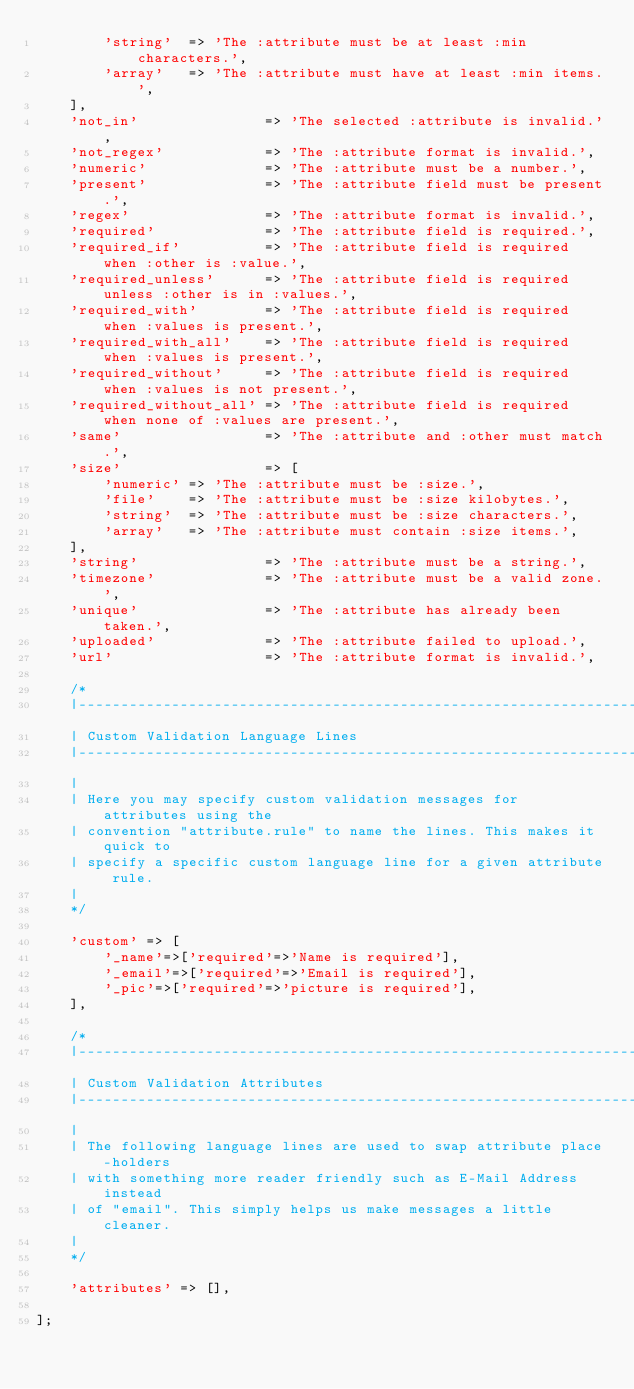<code> <loc_0><loc_0><loc_500><loc_500><_PHP_>        'string'  => 'The :attribute must be at least :min characters.',
        'array'   => 'The :attribute must have at least :min items.',
    ],
    'not_in'               => 'The selected :attribute is invalid.',
    'not_regex'            => 'The :attribute format is invalid.',
    'numeric'              => 'The :attribute must be a number.',
    'present'              => 'The :attribute field must be present.',
    'regex'                => 'The :attribute format is invalid.',
    'required'             => 'The :attribute field is required.',
    'required_if'          => 'The :attribute field is required when :other is :value.',
    'required_unless'      => 'The :attribute field is required unless :other is in :values.',
    'required_with'        => 'The :attribute field is required when :values is present.',
    'required_with_all'    => 'The :attribute field is required when :values is present.',
    'required_without'     => 'The :attribute field is required when :values is not present.',
    'required_without_all' => 'The :attribute field is required when none of :values are present.',
    'same'                 => 'The :attribute and :other must match.',
    'size'                 => [
        'numeric' => 'The :attribute must be :size.',
        'file'    => 'The :attribute must be :size kilobytes.',
        'string'  => 'The :attribute must be :size characters.',
        'array'   => 'The :attribute must contain :size items.',
    ],
    'string'               => 'The :attribute must be a string.',
    'timezone'             => 'The :attribute must be a valid zone.',
    'unique'               => 'The :attribute has already been taken.',
    'uploaded'             => 'The :attribute failed to upload.',
    'url'                  => 'The :attribute format is invalid.',

    /*
    |--------------------------------------------------------------------------
    | Custom Validation Language Lines
    |--------------------------------------------------------------------------
    |
    | Here you may specify custom validation messages for attributes using the
    | convention "attribute.rule" to name the lines. This makes it quick to
    | specify a specific custom language line for a given attribute rule.
    |
    */

    'custom' => [
        '_name'=>['required'=>'Name is required'],
        '_email'=>['required'=>'Email is required'],
        '_pic'=>['required'=>'picture is required'],
    ],

    /*
    |--------------------------------------------------------------------------
    | Custom Validation Attributes
    |--------------------------------------------------------------------------
    |
    | The following language lines are used to swap attribute place-holders
    | with something more reader friendly such as E-Mail Address instead
    | of "email". This simply helps us make messages a little cleaner.
    |
    */

    'attributes' => [],

];
</code> 